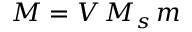Convert formula to latex. <formula><loc_0><loc_0><loc_500><loc_500>M = V \, M _ { s } \, m</formula> 